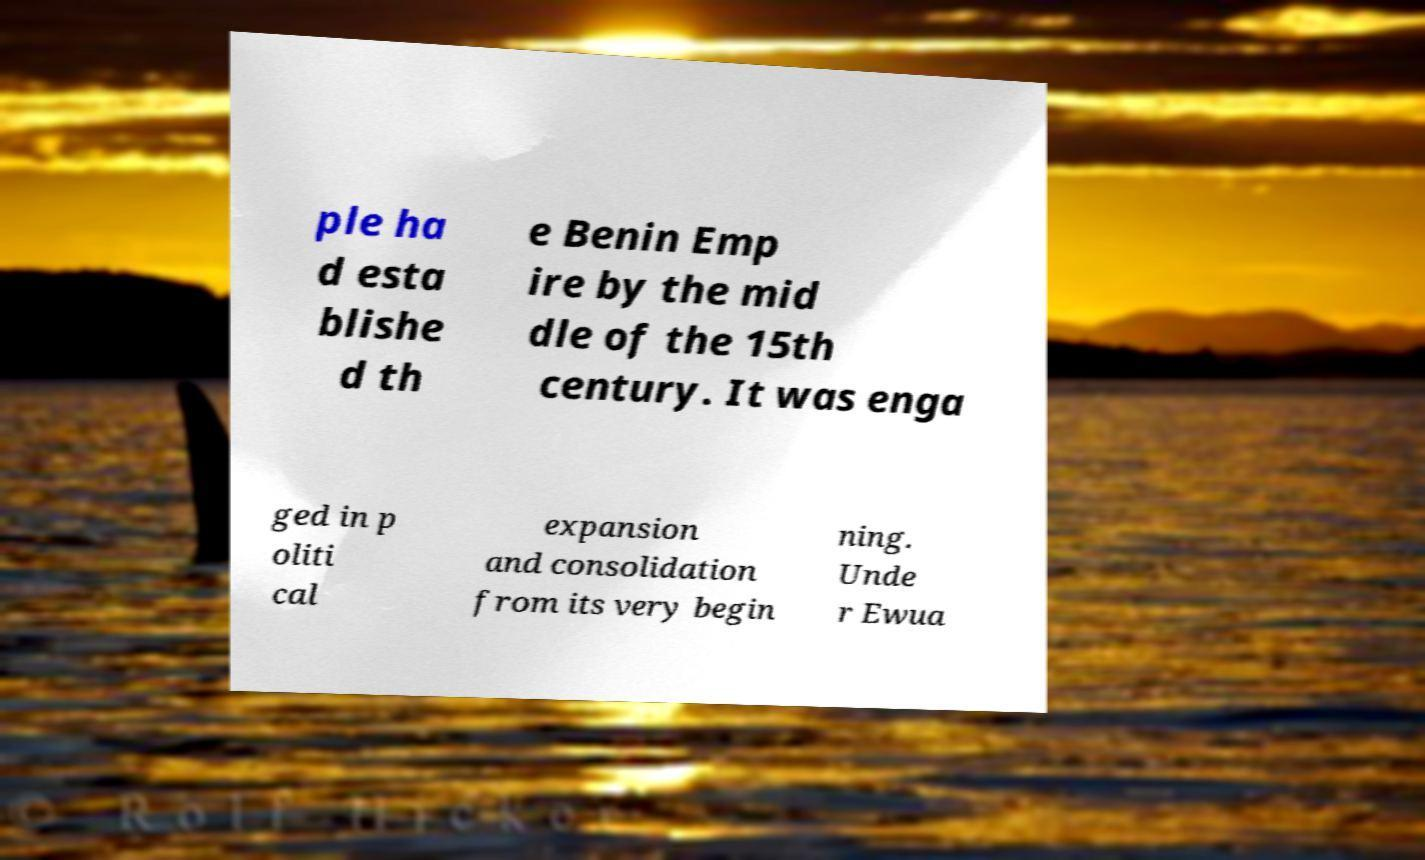Could you extract and type out the text from this image? ple ha d esta blishe d th e Benin Emp ire by the mid dle of the 15th century. It was enga ged in p oliti cal expansion and consolidation from its very begin ning. Unde r Ewua 